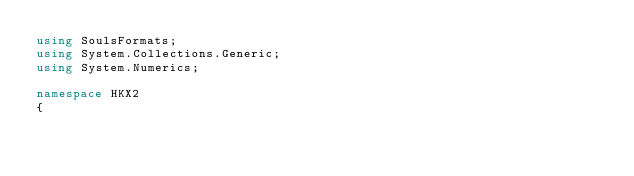<code> <loc_0><loc_0><loc_500><loc_500><_C#_>using SoulsFormats;
using System.Collections.Generic;
using System.Numerics;

namespace HKX2
{</code> 